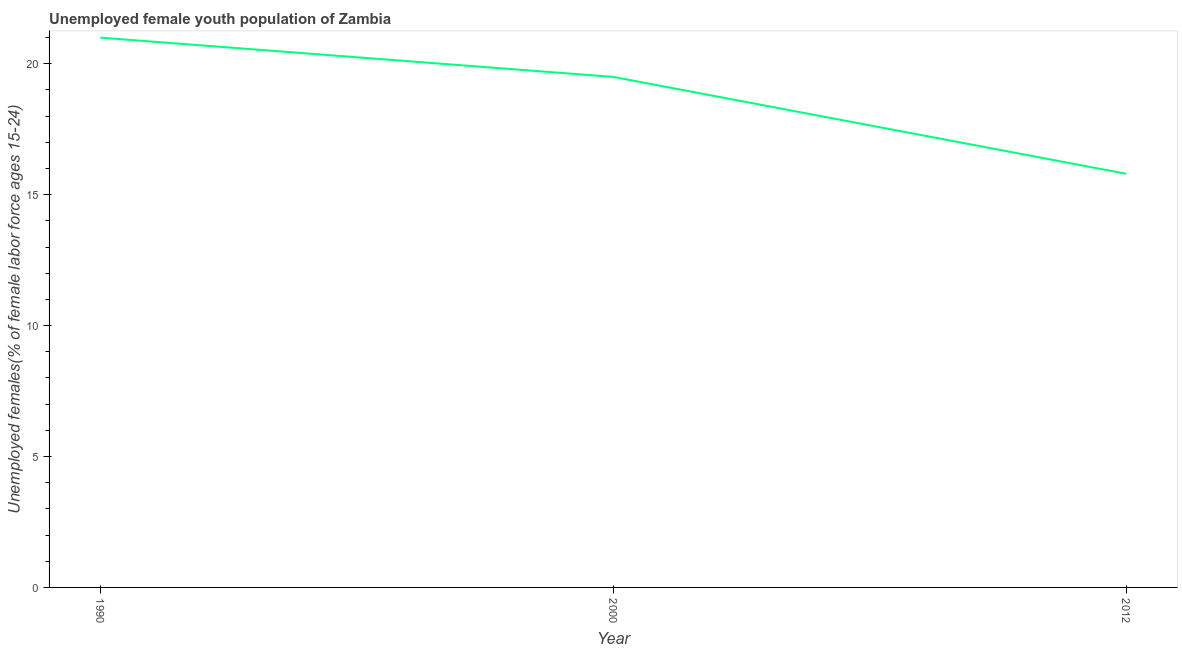Across all years, what is the maximum unemployed female youth?
Your response must be concise. 21. Across all years, what is the minimum unemployed female youth?
Offer a very short reply. 15.8. In which year was the unemployed female youth maximum?
Ensure brevity in your answer.  1990. In which year was the unemployed female youth minimum?
Provide a succinct answer. 2012. What is the sum of the unemployed female youth?
Ensure brevity in your answer.  56.3. What is the difference between the unemployed female youth in 2000 and 2012?
Offer a very short reply. 3.7. What is the average unemployed female youth per year?
Offer a very short reply. 18.77. What is the median unemployed female youth?
Offer a terse response. 19.5. In how many years, is the unemployed female youth greater than 12 %?
Keep it short and to the point. 3. Do a majority of the years between 1990 and 2012 (inclusive) have unemployed female youth greater than 16 %?
Provide a succinct answer. Yes. What is the ratio of the unemployed female youth in 1990 to that in 2000?
Your answer should be very brief. 1.08. Is the unemployed female youth in 1990 less than that in 2000?
Your answer should be compact. No. Is the difference between the unemployed female youth in 1990 and 2012 greater than the difference between any two years?
Provide a succinct answer. Yes. What is the difference between the highest and the second highest unemployed female youth?
Ensure brevity in your answer.  1.5. Is the sum of the unemployed female youth in 2000 and 2012 greater than the maximum unemployed female youth across all years?
Keep it short and to the point. Yes. What is the difference between the highest and the lowest unemployed female youth?
Give a very brief answer. 5.2. Does the unemployed female youth monotonically increase over the years?
Your answer should be very brief. No. Does the graph contain any zero values?
Offer a very short reply. No. Does the graph contain grids?
Give a very brief answer. No. What is the title of the graph?
Your response must be concise. Unemployed female youth population of Zambia. What is the label or title of the Y-axis?
Provide a short and direct response. Unemployed females(% of female labor force ages 15-24). What is the Unemployed females(% of female labor force ages 15-24) of 2000?
Your answer should be compact. 19.5. What is the Unemployed females(% of female labor force ages 15-24) in 2012?
Your answer should be very brief. 15.8. What is the difference between the Unemployed females(% of female labor force ages 15-24) in 1990 and 2012?
Give a very brief answer. 5.2. What is the ratio of the Unemployed females(% of female labor force ages 15-24) in 1990 to that in 2000?
Ensure brevity in your answer.  1.08. What is the ratio of the Unemployed females(% of female labor force ages 15-24) in 1990 to that in 2012?
Provide a short and direct response. 1.33. What is the ratio of the Unemployed females(% of female labor force ages 15-24) in 2000 to that in 2012?
Offer a very short reply. 1.23. 